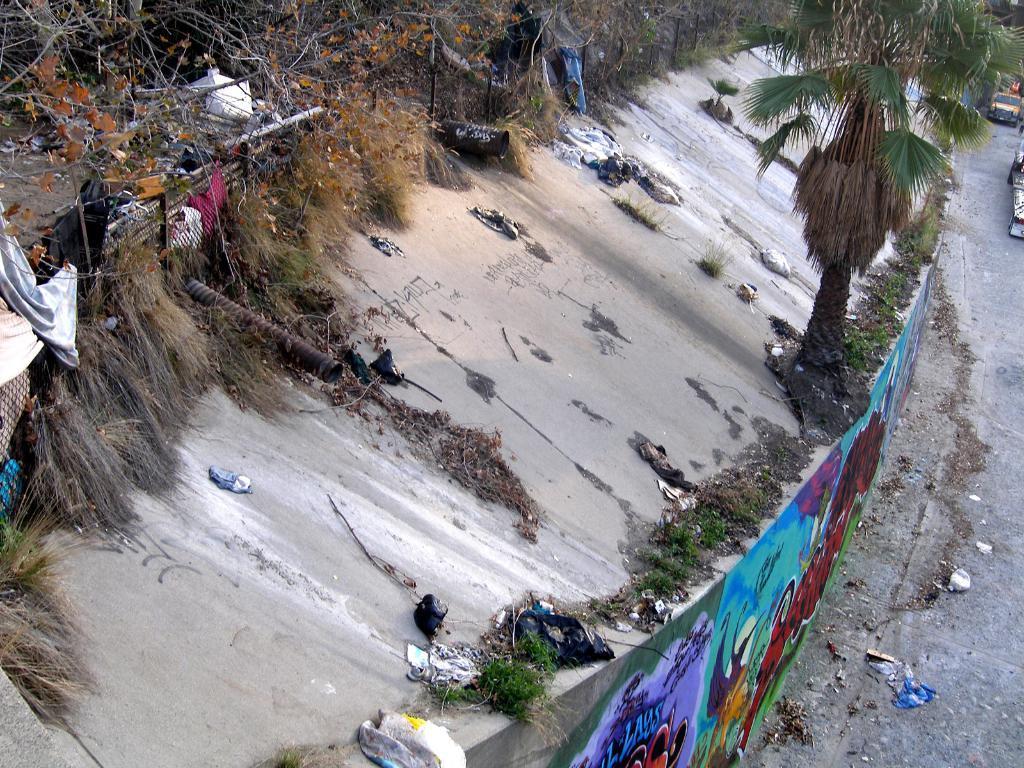Can you describe this image briefly? In this picture we can see some painting on the wall. We can see some grass, few clothes, wooden objects and some trees. There are few vehicles on the road. 